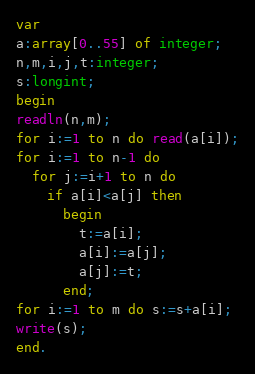Convert code to text. <code><loc_0><loc_0><loc_500><loc_500><_Pascal_>var
a:array[0..55] of integer;
n,m,i,j,t:integer;
s:longint;
begin
readln(n,m);
for i:=1 to n do read(a[i]);
for i:=1 to n-1 do
  for j:=i+1 to n do
    if a[i]<a[j] then
      begin
        t:=a[i];
        a[i]:=a[j];
        a[j]:=t;
      end;
for i:=1 to m do s:=s+a[i];
write(s);
end.</code> 